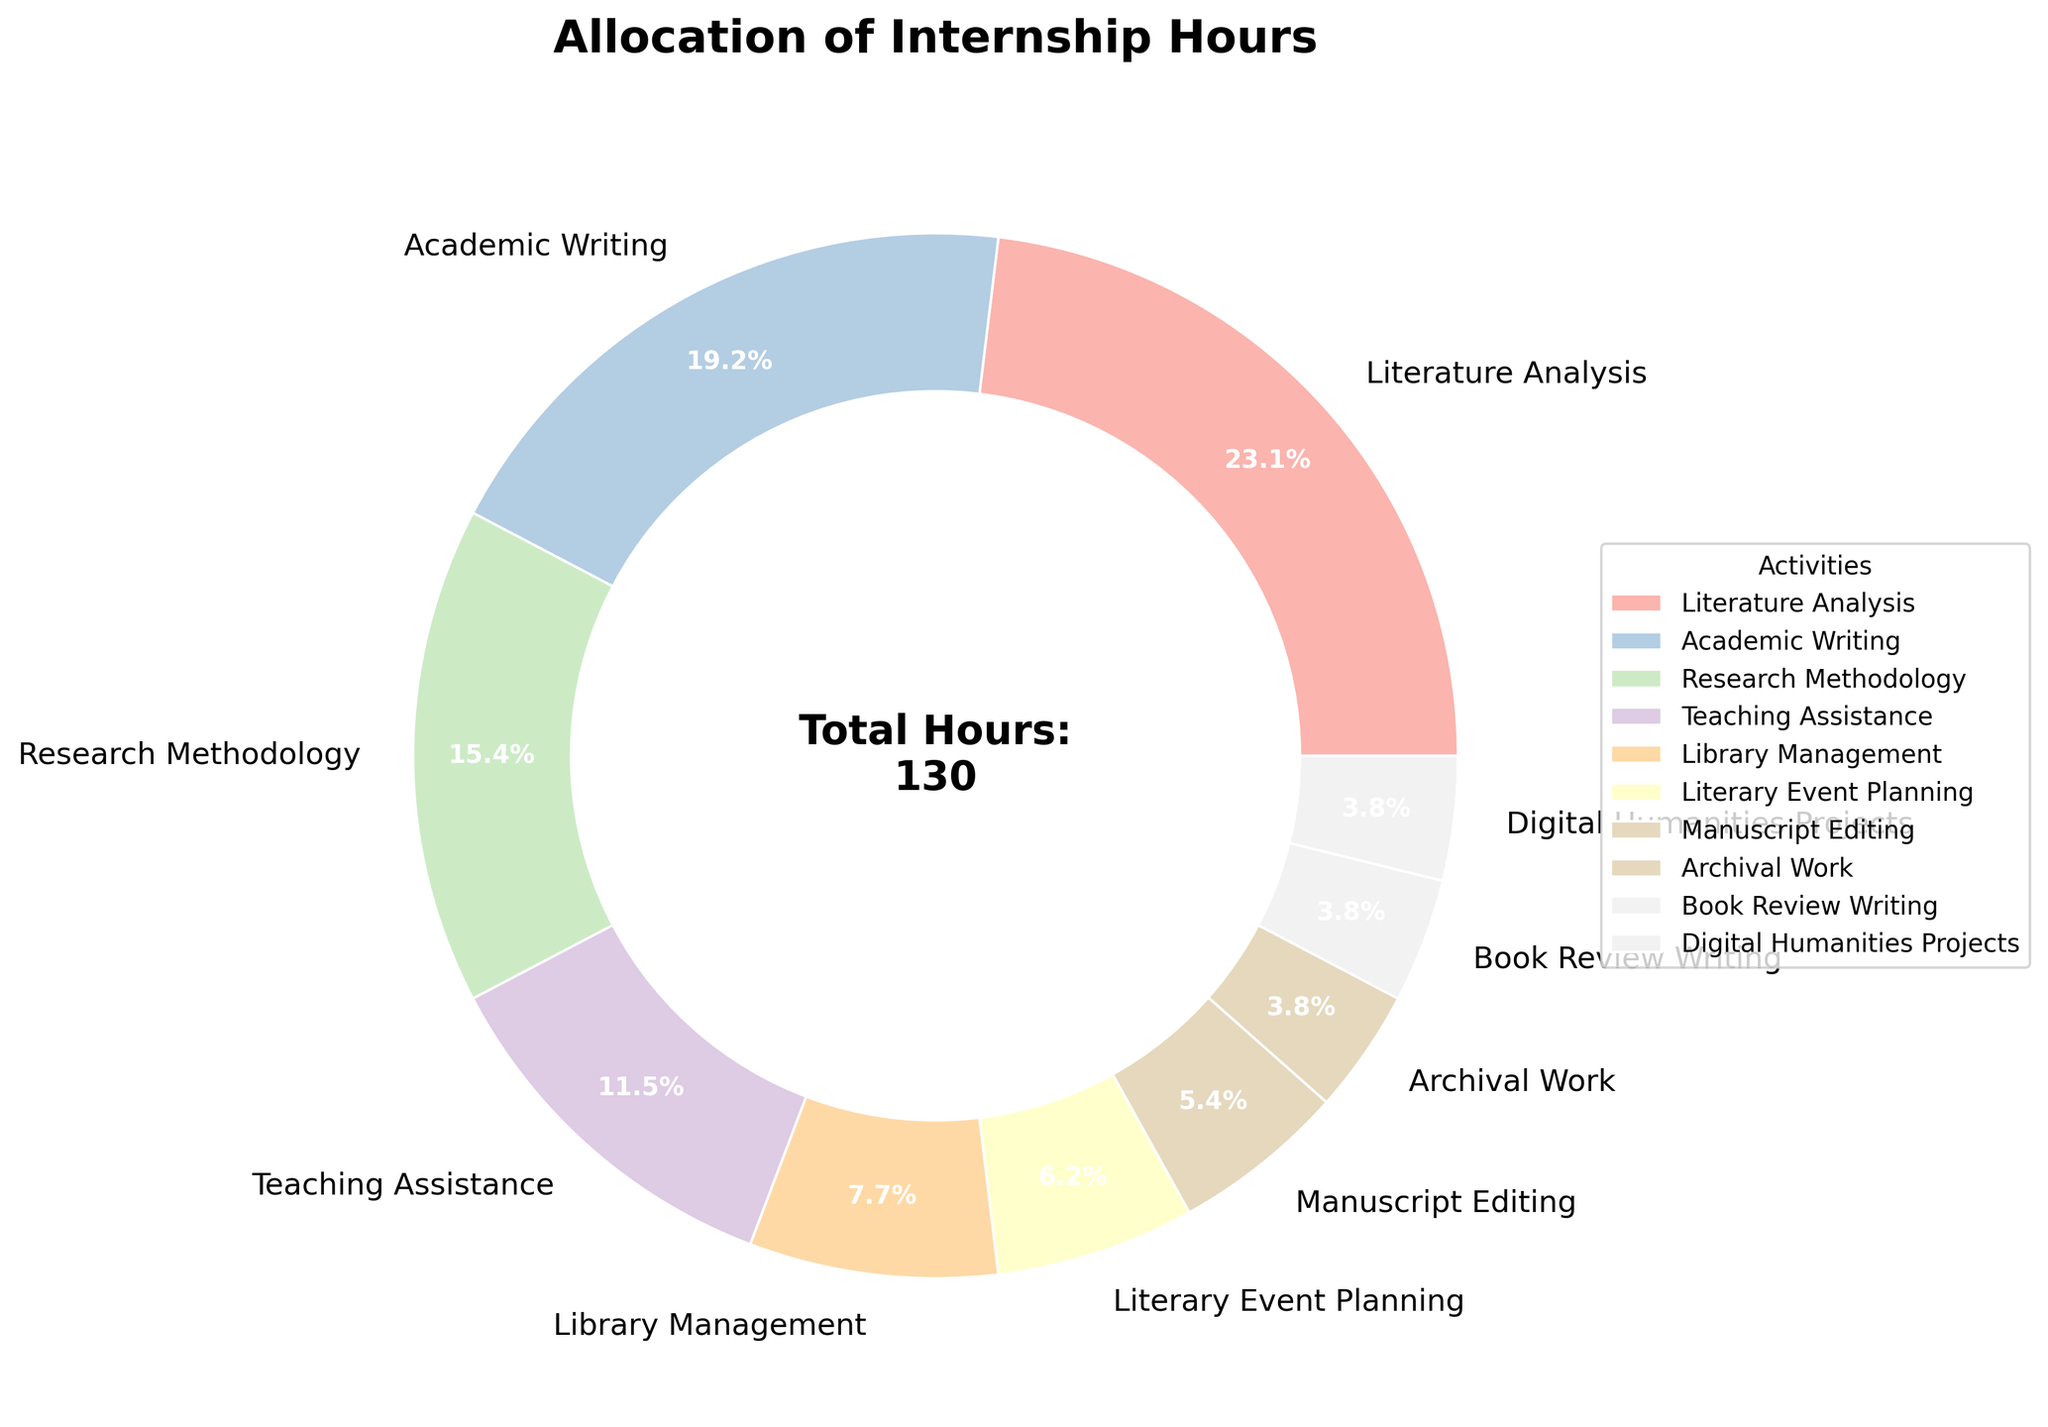What activity has the highest allocation of hours? By inspecting the pie chart, we can see that "Literature Analysis" takes up the largest section of the pie, indicating it has the highest allocation of hours.
Answer: Literature Analysis What percentage of total internship hours is allocated to Academic Writing and Research Methodology combined? The pie chart shows that Academic Writing has 25% and Research Methodology has 20%. Adding these percentages together gives us 25% + 20% = 45%.
Answer: 45% Which activities have an equal allocation of hours? The pie chart indicates that "Book Review Writing," "Digital Humanities Projects," and "Archival Work" each have the same, smallest section, meaning they share an equal allocation of hours, which is 5 hours each.
Answer: Book Review Writing, Digital Humanities Projects, Archival Work What is the difference in hours between Literature Analysis and Teaching Assistance? Literature Analysis has 30 hours and Teaching Assistance has 15 hours. Subtracting these gives 30 - 15 = 15 hours.
Answer: 15 hours Which activity takes up more hours, Literary Event Planning or Manuscript Editing? According to the pie chart, Literary Event Planning has 8 hours while Manuscript Editing has 7 hours, so Literary Event Planning has more hours.
Answer: Literary Event Planning What portion of the total hours are spent on activities involving direct interaction with literature (Literature Analysis, Academic Writing, Manuscript Editing)? Summing the hours for Literature Analysis (30 hours), Academic Writing (25 hours), and Manuscript Editing (7 hours) gives us 30 + 25 + 7 = 62 hours. To find the percentage, we use (62 hours / 130 total hours) * 100%, which is approximately 47.7%.
Answer: 47.7% How do the hours allocated to Library Management compare to those allocated to Archival Work? Library Management has 10 hours, whereas Archival Work has 5 hours as shown by the pie chart. Thus, Library Management is allocated twice as many hours as Archival Work.
Answer: Library Management is twice as much as Archival Work What is the least allocated activity, and how many hours are assigned to it? Examining the smaller sections of the pie chart, "Book Review Writing," "Digital Humanities Projects," and "Archival Work" are tied as the least allocated activities, each with 5 hours.
Answer: Book Review Writing, Digital Humanities Projects, and Archival Work; 5 hours each What proportion of total hours do the administrative activities (Library Management and Literary Event Planning) account for? Library Management has 10 hours, Literary Event Planning has 8 hours. Summing these hours gives us 10 + 8 = 18 hours. To find the percentage, we use (18 hours / 130 total hours) * 100%, which is approximately 13.8%.
Answer: 13.8% Are there any activities where the hours allocated are less than half of those allocated for Academic Writing? According to the pie chart, Academic Writing has 25 hours. Half of this is 12.5 hours. Activities with fewer than 12.5 hours are Library Management (10 hours), Literary Event Planning (8 hours), Manuscript Editing (7 hours), Archival Work (5 hours), Book Review Writing (5 hours), and Digital Humanities Projects (5 hours).
Answer: Library Management, Literary Event Planning, Manuscript Editing, Archival Work, Book Review Writing, Digital Humanities Projects 